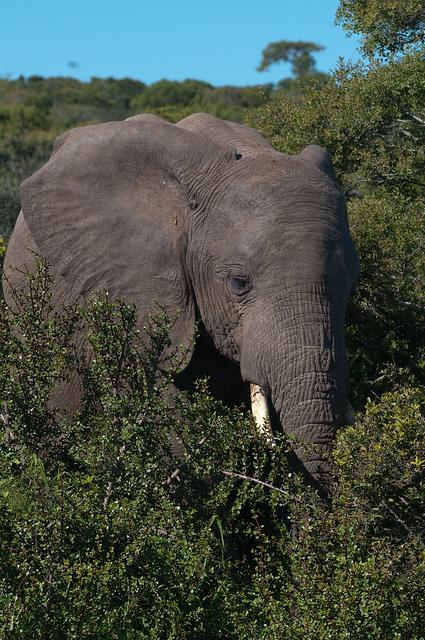Is the elephant sick?
Answer briefly. No. What is the animal standing in?
Keep it brief. Bushes. What color is the elephant?
Keep it brief. Gray. What is the elephant doing?
Keep it brief. Standing. Does the elephant have tusks?
Write a very short answer. Yes. How many legs of the elephant are shown?
Answer briefly. 0. What is the animal doing?
Answer briefly. Eating. Does this elephant have tusks?
Quick response, please. Yes. Are the elephant's eyes closed?
Quick response, please. No. What is he eating?
Answer briefly. Leaves. 